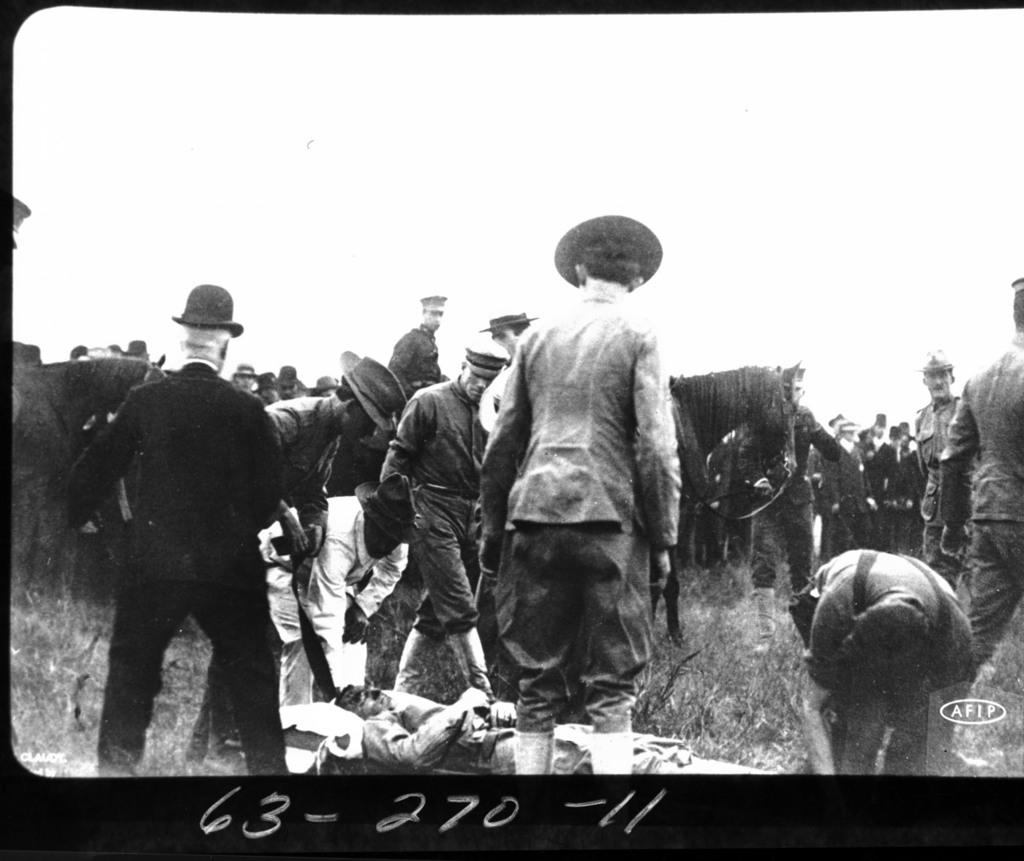What is present in the image that contains both images and text? There is a poster in the image that contains images and text. Can you see anyone smiling in the image? There is no person present in the image, so it is not possible to see anyone smiling. 